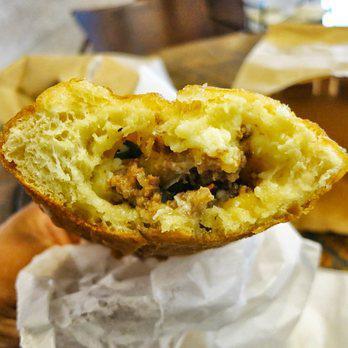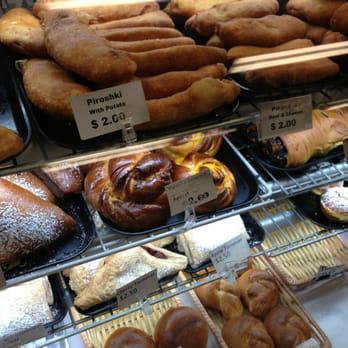The first image is the image on the left, the second image is the image on the right. Analyze the images presented: Is the assertion "Windows can be seen in the image on the left." valid? Answer yes or no. No. 